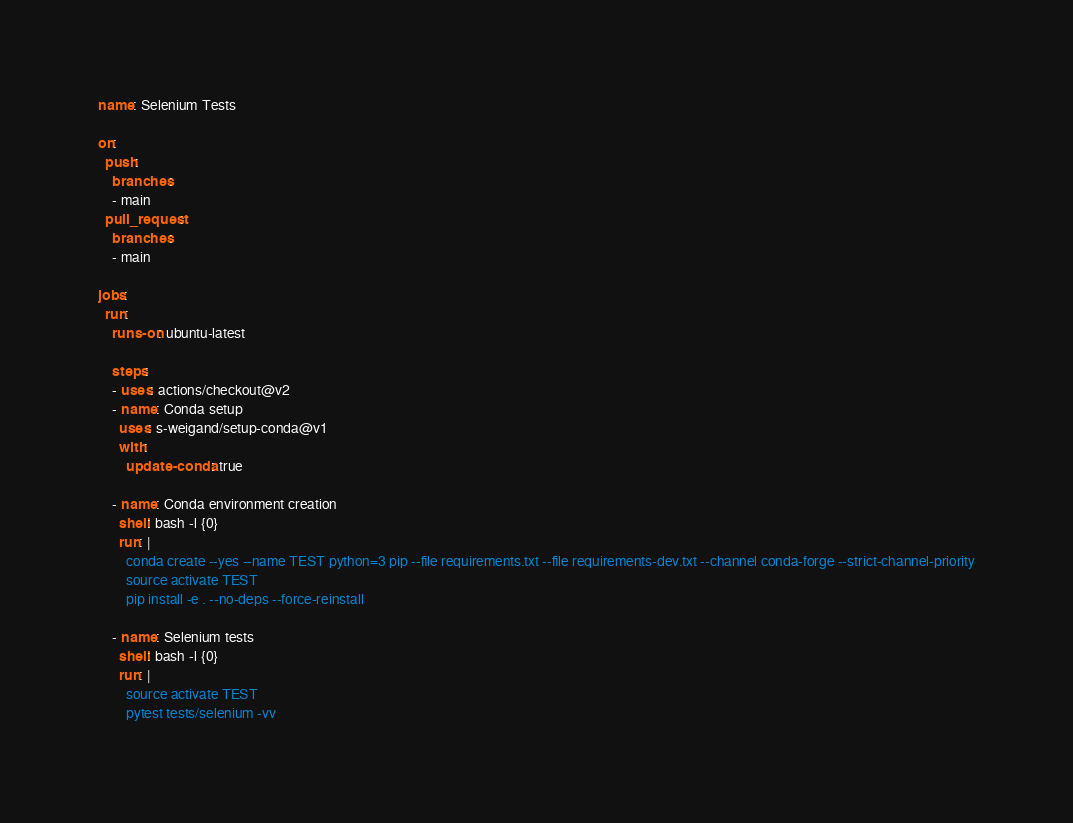<code> <loc_0><loc_0><loc_500><loc_500><_YAML_>name: Selenium Tests

on:
  push:
    branches:
    - main
  pull_request:
    branches:
    - main

jobs:
  run:
    runs-on: ubuntu-latest

    steps:
    - uses: actions/checkout@v2
    - name: Conda setup
      uses: s-weigand/setup-conda@v1
      with:
        update-conda: true

    - name: Conda environment creation
      shell: bash -l {0}
      run: |
        conda create --yes --name TEST python=3 pip --file requirements.txt --file requirements-dev.txt --channel conda-forge --strict-channel-priority
        source activate TEST
        pip install -e . --no-deps --force-reinstall

    - name: Selenium tests
      shell: bash -l {0}
      run: |
        source activate TEST
        pytest tests/selenium -vv
</code> 